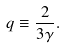Convert formula to latex. <formula><loc_0><loc_0><loc_500><loc_500>q \equiv \frac { 2 } { 3 \gamma } .</formula> 